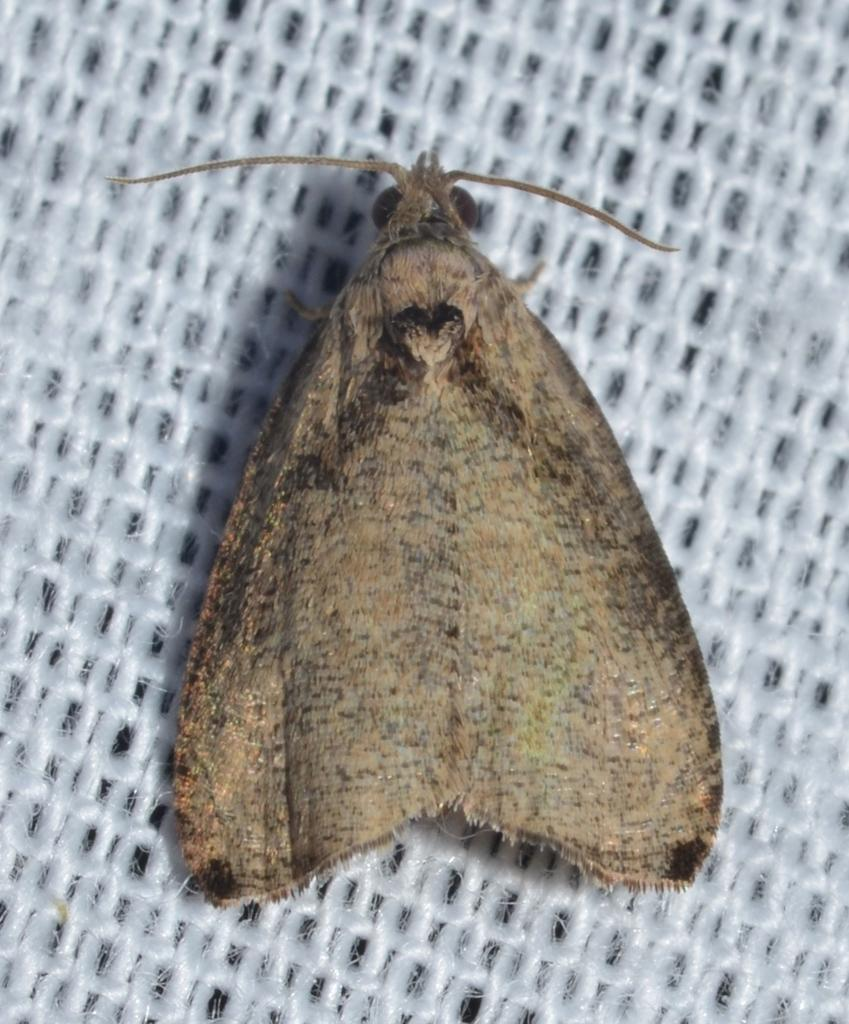What type of creature is present in the image? There is an insect in the image. Where is the insect located? The insect is on a white mesh. How many cameras can be seen in the image? There are no cameras present in the image; it features an insect on a white mesh. What type of body is visible in the image? There is no body visible in the image; it features an insect on a white mesh. 